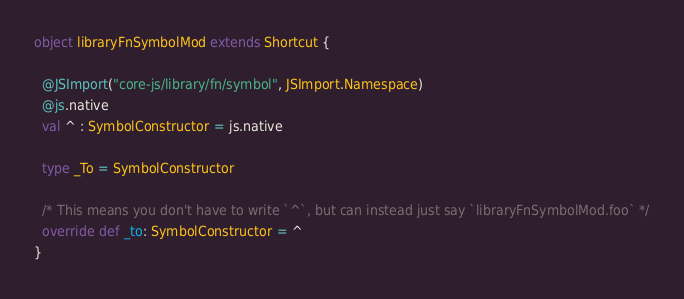Convert code to text. <code><loc_0><loc_0><loc_500><loc_500><_Scala_>
object libraryFnSymbolMod extends Shortcut {
  
  @JSImport("core-js/library/fn/symbol", JSImport.Namespace)
  @js.native
  val ^ : SymbolConstructor = js.native
  
  type _To = SymbolConstructor
  
  /* This means you don't have to write `^`, but can instead just say `libraryFnSymbolMod.foo` */
  override def _to: SymbolConstructor = ^
}
</code> 